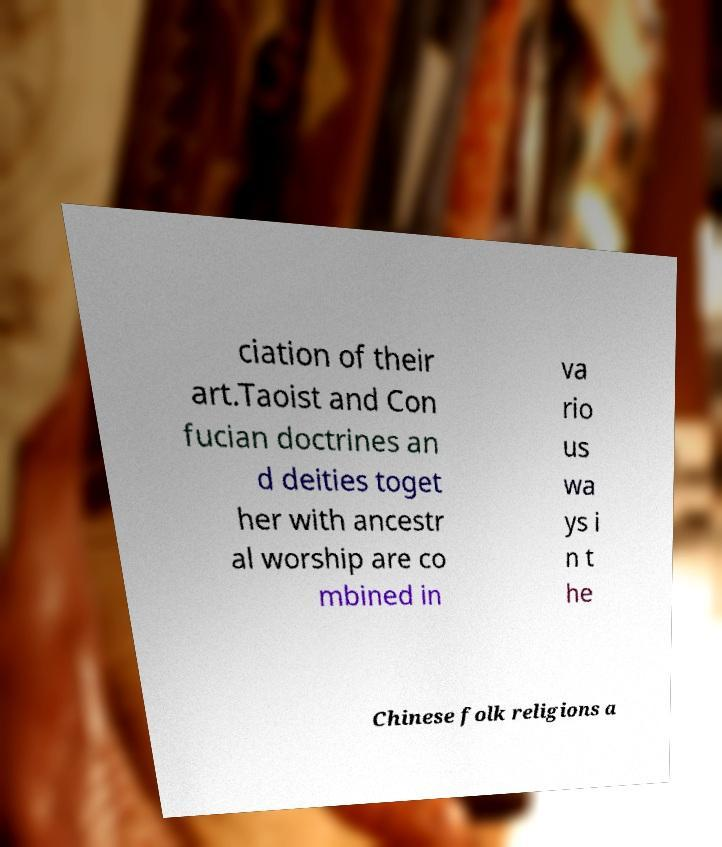Please read and relay the text visible in this image. What does it say? ciation of their art.Taoist and Con fucian doctrines an d deities toget her with ancestr al worship are co mbined in va rio us wa ys i n t he Chinese folk religions a 